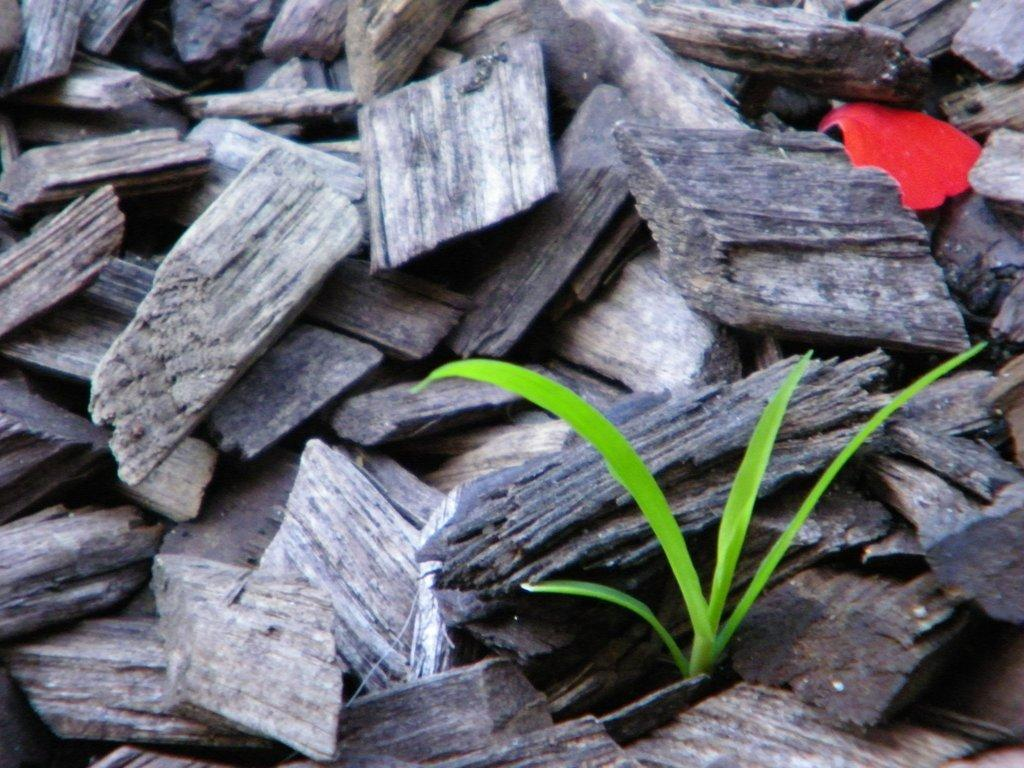What type of material is used for the pieces in the image? The wooden pieces in the image are made of wood. What other object can be seen in the image besides the wooden pieces? There is a flower petal in the image. What is the color and texture of the ground in the image? Green grass is visible in the image. What type of bun is being used to hold the flower petal in the image? There is no bun present in the image; the flower petal is not being held by any object. What kind of paste is being used to attach the wooden pieces together in the image? There is no paste visible in the image, and the wooden pieces are not attached to each other. 